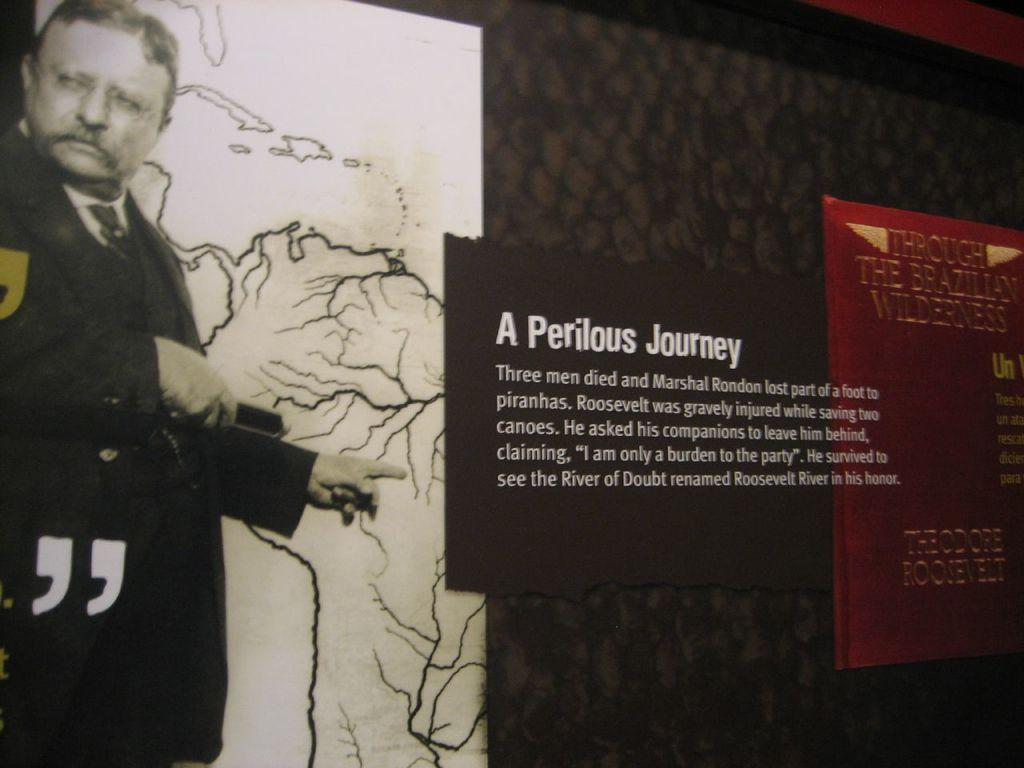<image>
Write a terse but informative summary of the picture. A display from a museum titled A Perilous Journey 